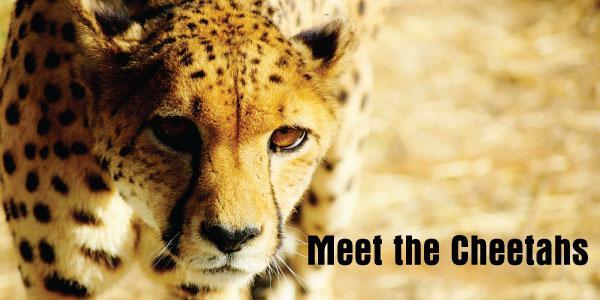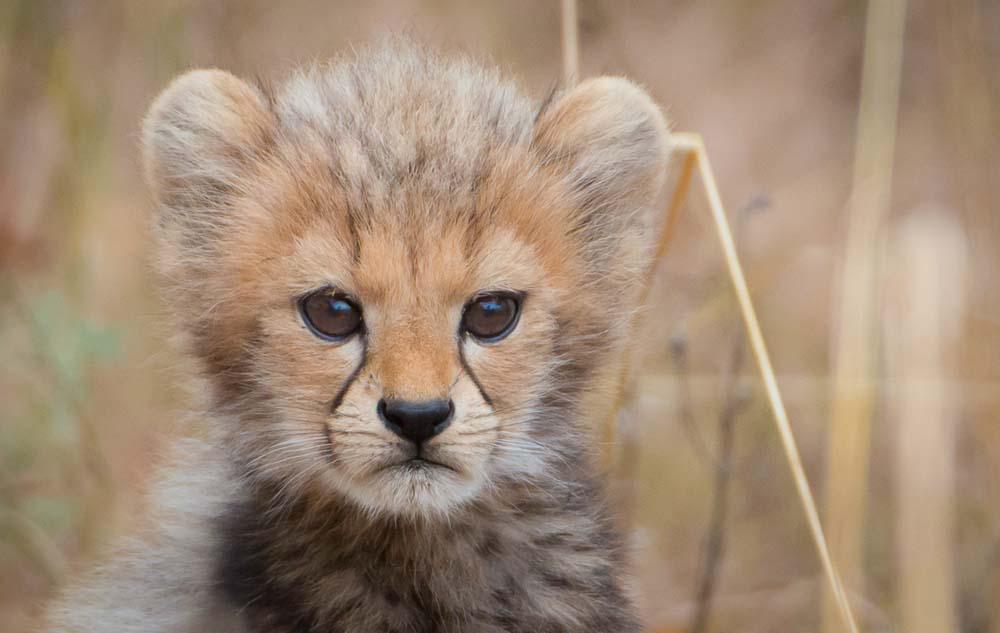The first image is the image on the left, the second image is the image on the right. For the images shown, is this caption "The left image includes at least one cheetah in a reclining pose with both its front paws forward, and the right image includes a cheetah with a blood-drenched muzzle." true? Answer yes or no. No. The first image is the image on the left, the second image is the image on the right. Given the left and right images, does the statement "At least one cheetah has blood around its mouth." hold true? Answer yes or no. No. 